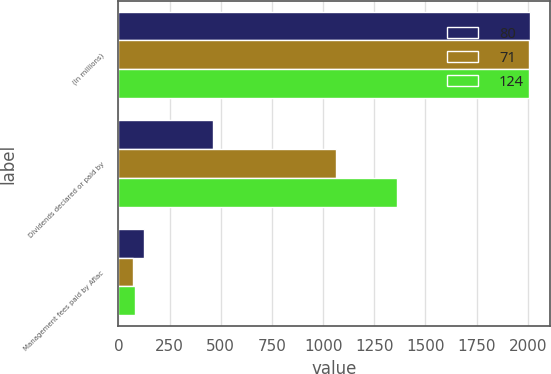<chart> <loc_0><loc_0><loc_500><loc_500><stacked_bar_chart><ecel><fcel>(In millions)<fcel>Dividends declared or paid by<fcel>Management fees paid by Aflac<nl><fcel>80<fcel>2009<fcel>464<fcel>124<nl><fcel>71<fcel>2008<fcel>1062<fcel>71<nl><fcel>124<fcel>2007<fcel>1362<fcel>80<nl></chart> 